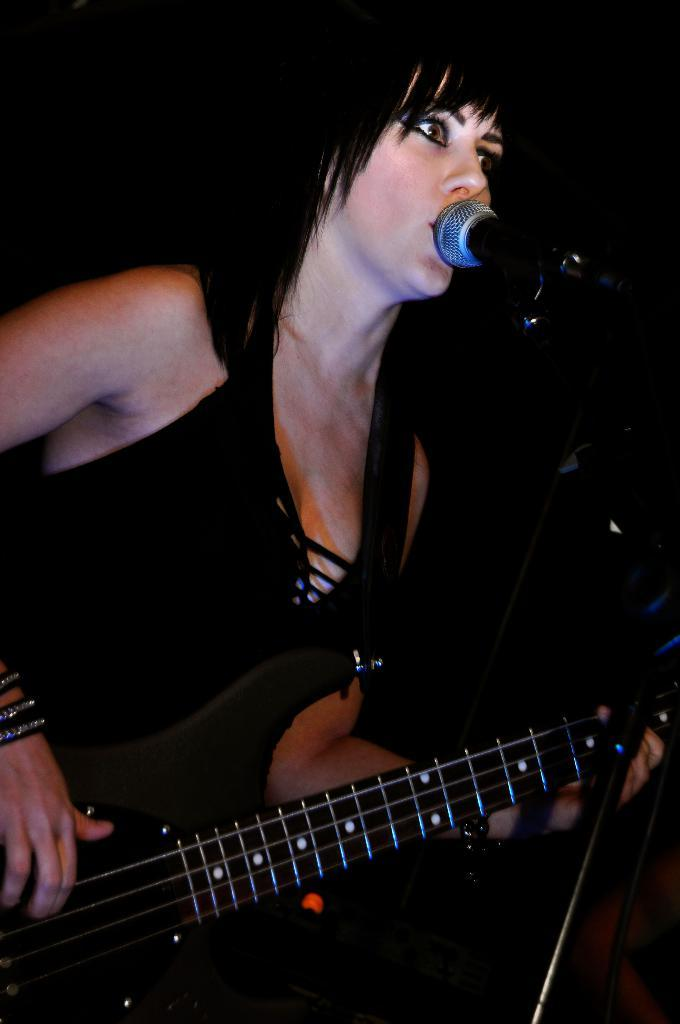Who is the main subject in the image? There is a lady in the image. What is the lady wearing? The lady is wearing a black dress. What is the lady doing in the image? The lady is standing and playing a guitar. What object is in front of the lady? There is a microphone in front of the lady. What type of farming equipment can be seen in the hands of the lady in the image? There is no farming equipment present in the image; the lady is playing a guitar. How does the coach instruct the lady in the image? There is no coach present in the image, and the lady is playing a guitar independently. 